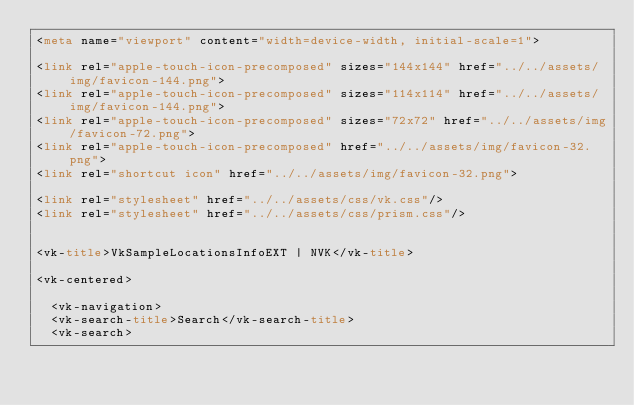Convert code to text. <code><loc_0><loc_0><loc_500><loc_500><_HTML_><meta name="viewport" content="width=device-width, initial-scale=1">

<link rel="apple-touch-icon-precomposed" sizes="144x144" href="../../assets/img/favicon-144.png">
<link rel="apple-touch-icon-precomposed" sizes="114x114" href="../../assets/img/favicon-144.png">
<link rel="apple-touch-icon-precomposed" sizes="72x72" href="../../assets/img/favicon-72.png">
<link rel="apple-touch-icon-precomposed" href="../../assets/img/favicon-32.png">
<link rel="shortcut icon" href="../../assets/img/favicon-32.png">

<link rel="stylesheet" href="../../assets/css/vk.css"/>
<link rel="stylesheet" href="../../assets/css/prism.css"/>


<vk-title>VkSampleLocationsInfoEXT | NVK</vk-title>

<vk-centered>

  <vk-navigation>
  <vk-search-title>Search</vk-search-title>
  <vk-search></code> 